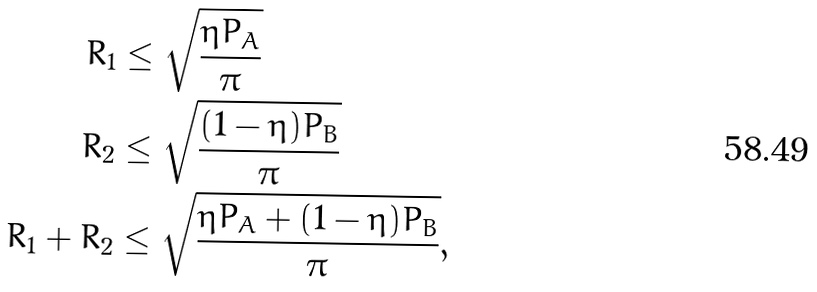Convert formula to latex. <formula><loc_0><loc_0><loc_500><loc_500>R _ { 1 } & \leq \sqrt { \frac { \eta P _ { A } } { \pi } } \\ R _ { 2 } & \leq \sqrt { \frac { ( 1 - \eta ) P _ { B } } { \pi } } \\ R _ { 1 } + R _ { 2 } & \leq \sqrt { \frac { \eta P _ { A } + ( 1 - \eta ) P _ { B } } { \pi } } ,</formula> 